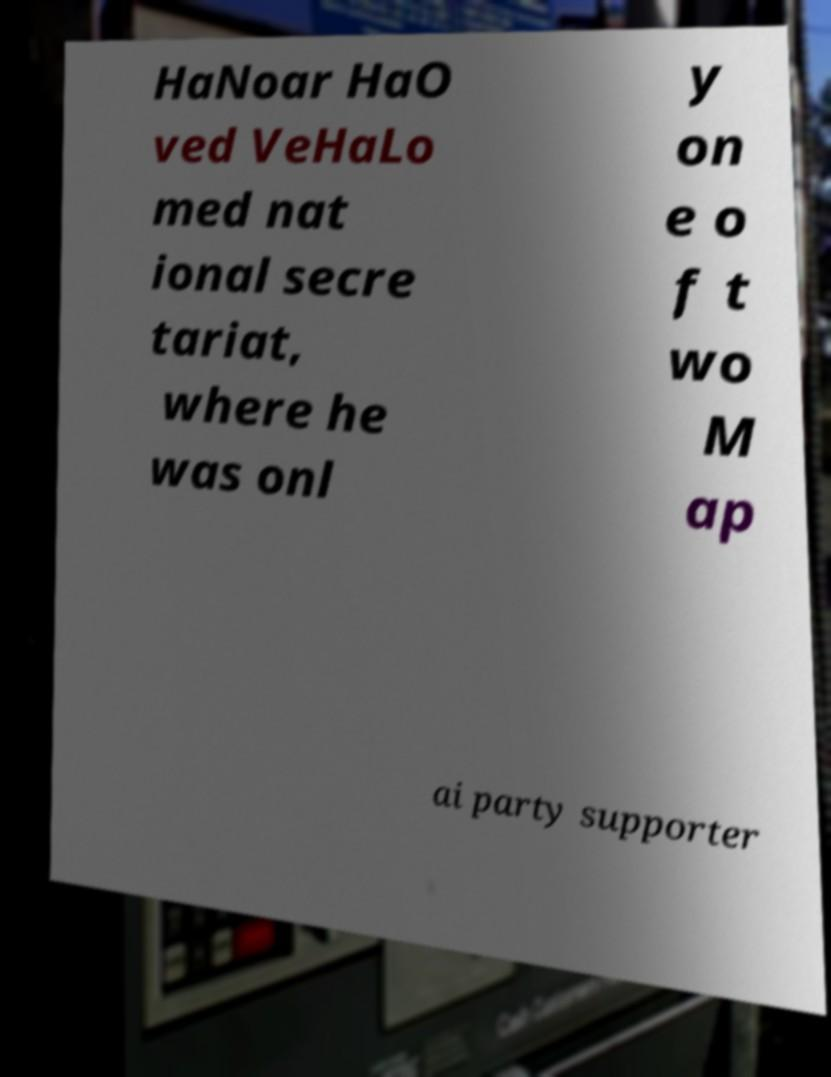I need the written content from this picture converted into text. Can you do that? HaNoar HaO ved VeHaLo med nat ional secre tariat, where he was onl y on e o f t wo M ap ai party supporter 